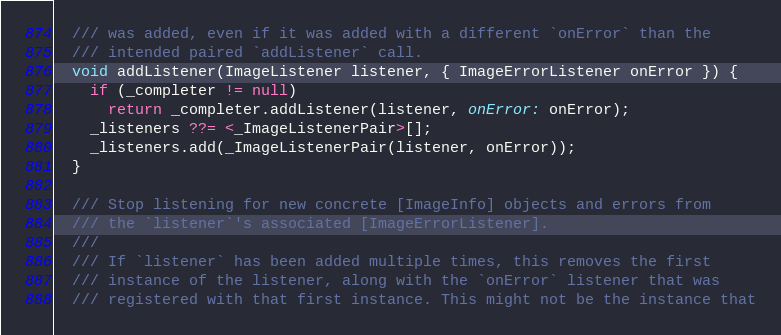<code> <loc_0><loc_0><loc_500><loc_500><_Dart_>  /// was added, even if it was added with a different `onError` than the
  /// intended paired `addListener` call.
  void addListener(ImageListener listener, { ImageErrorListener onError }) {
    if (_completer != null)
      return _completer.addListener(listener, onError: onError);
    _listeners ??= <_ImageListenerPair>[];
    _listeners.add(_ImageListenerPair(listener, onError));
  }

  /// Stop listening for new concrete [ImageInfo] objects and errors from
  /// the `listener`'s associated [ImageErrorListener].
  ///
  /// If `listener` has been added multiple times, this removes the first
  /// instance of the listener, along with the `onError` listener that was
  /// registered with that first instance. This might not be the instance that</code> 